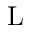<formula> <loc_0><loc_0><loc_500><loc_500>L</formula> 